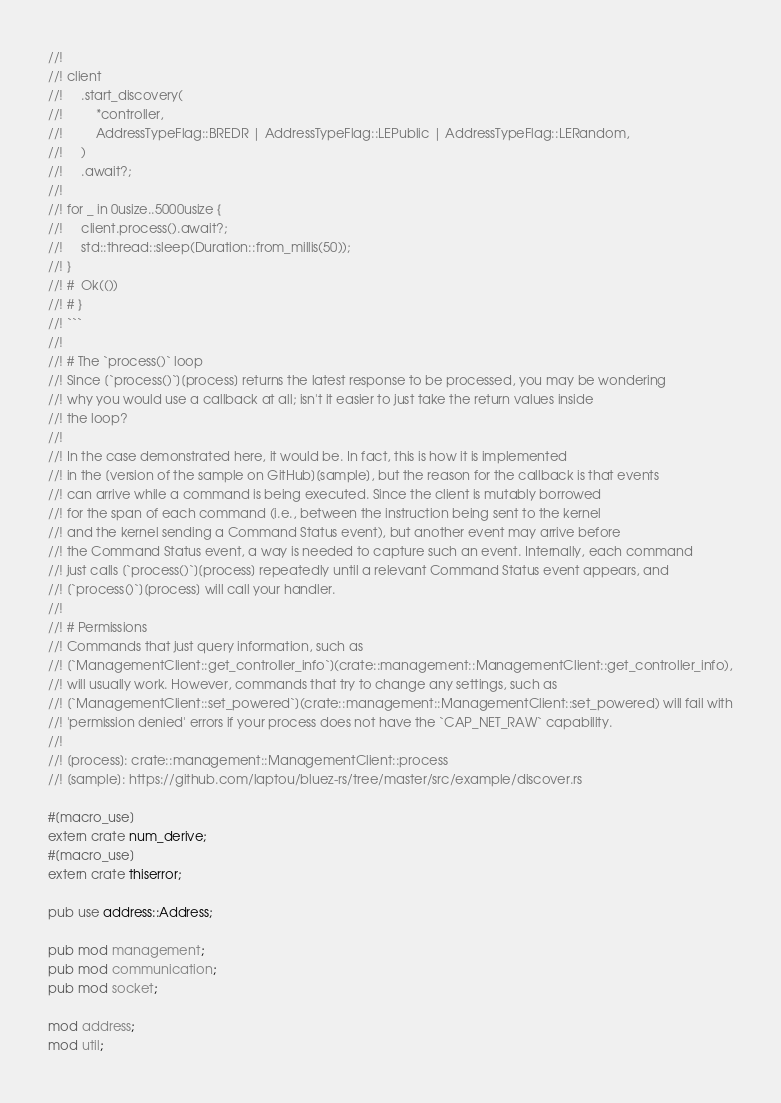<code> <loc_0><loc_0><loc_500><loc_500><_Rust_>//!
//! client
//!     .start_discovery(
//!         *controller,
//!         AddressTypeFlag::BREDR | AddressTypeFlag::LEPublic | AddressTypeFlag::LERandom,
//!     )
//!     .await?;
//!
//! for _ in 0usize..5000usize {
//!     client.process().await?;
//!     std::thread::sleep(Duration::from_millis(50));
//! }
//! #  Ok(())
//! # }
//! ```
//!
//! # The `process()` loop
//! Since [`process()`][process] returns the latest response to be processed, you may be wondering
//! why you would use a callback at all; isn't it easier to just take the return values inside
//! the loop?
//!
//! In the case demonstrated here, it would be. In fact, this is how it is implemented
//! in the [version of the sample on GitHub][sample], but the reason for the callback is that events
//! can arrive while a command is being executed. Since the client is mutably borrowed
//! for the span of each command (i.e., between the instruction being sent to the kernel
//! and the kernel sending a Command Status event), but another event may arrive before
//! the Command Status event, a way is needed to capture such an event. Internally, each command
//! just calls [`process()`][process] repeatedly until a relevant Command Status event appears, and
//! [`process()`][process] will call your handler.
//!
//! # Permissions
//! Commands that just query information, such as
//! [`ManagementClient::get_controller_info`](crate::management::ManagementClient::get_controller_info),
//! will usually work. However, commands that try to change any settings, such as
//! [`ManagementClient::set_powered`](crate::management::ManagementClient::set_powered) will fail with
//! 'permission denied' errors if your process does not have the `CAP_NET_RAW` capability.
//!
//! [process]: crate::management::ManagementClient::process
//! [sample]: https://github.com/laptou/bluez-rs/tree/master/src/example/discover.rs

#[macro_use]
extern crate num_derive;
#[macro_use]
extern crate thiserror;

pub use address::Address;

pub mod management;
pub mod communication;
pub mod socket;

mod address;
mod util;
</code> 